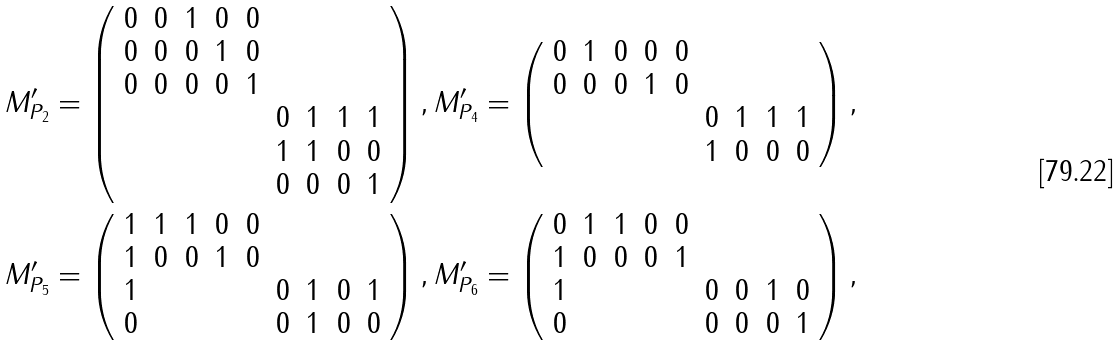Convert formula to latex. <formula><loc_0><loc_0><loc_500><loc_500>M ^ { \prime } _ { P _ { 2 } } = \left ( \begin{array} { c c c c c c c c c } 0 & 0 & 1 & 0 & 0 & & & & \\ 0 & 0 & 0 & 1 & 0 & & & & \\ 0 & 0 & 0 & 0 & 1 & & & & \\ & & & & & 0 & 1 & 1 & 1 \\ & & & & & 1 & 1 & 0 & 0 \\ & & & & & 0 & 0 & 0 & 1 \end{array} \right ) , M ^ { \prime } _ { P _ { 4 } } = \left ( \begin{array} { c c c c c c c c c } 0 & 1 & 0 & 0 & 0 & & & & \\ 0 & 0 & 0 & 1 & 0 & & & & \\ & & & & & 0 & 1 & 1 & 1 \\ & & & & & 1 & 0 & 0 & 0 \end{array} \right ) , \\ M ^ { \prime } _ { P _ { 5 } } = \left ( \begin{array} { c c c c c c c c c } 1 & 1 & 1 & 0 & 0 & & & & \\ 1 & 0 & 0 & 1 & 0 & & & & \\ 1 & & & & & 0 & 1 & 0 & 1 \\ 0 & & & & & 0 & 1 & 0 & 0 \end{array} \right ) , M ^ { \prime } _ { P _ { 6 } } = \left ( \begin{array} { c c c c c c c c c } 0 & 1 & 1 & 0 & 0 & & & & \\ 1 & 0 & 0 & 0 & 1 & & & & \\ 1 & & & & & 0 & 0 & 1 & 0 \\ 0 & & & & & 0 & 0 & 0 & 1 \end{array} \right ) ,</formula> 